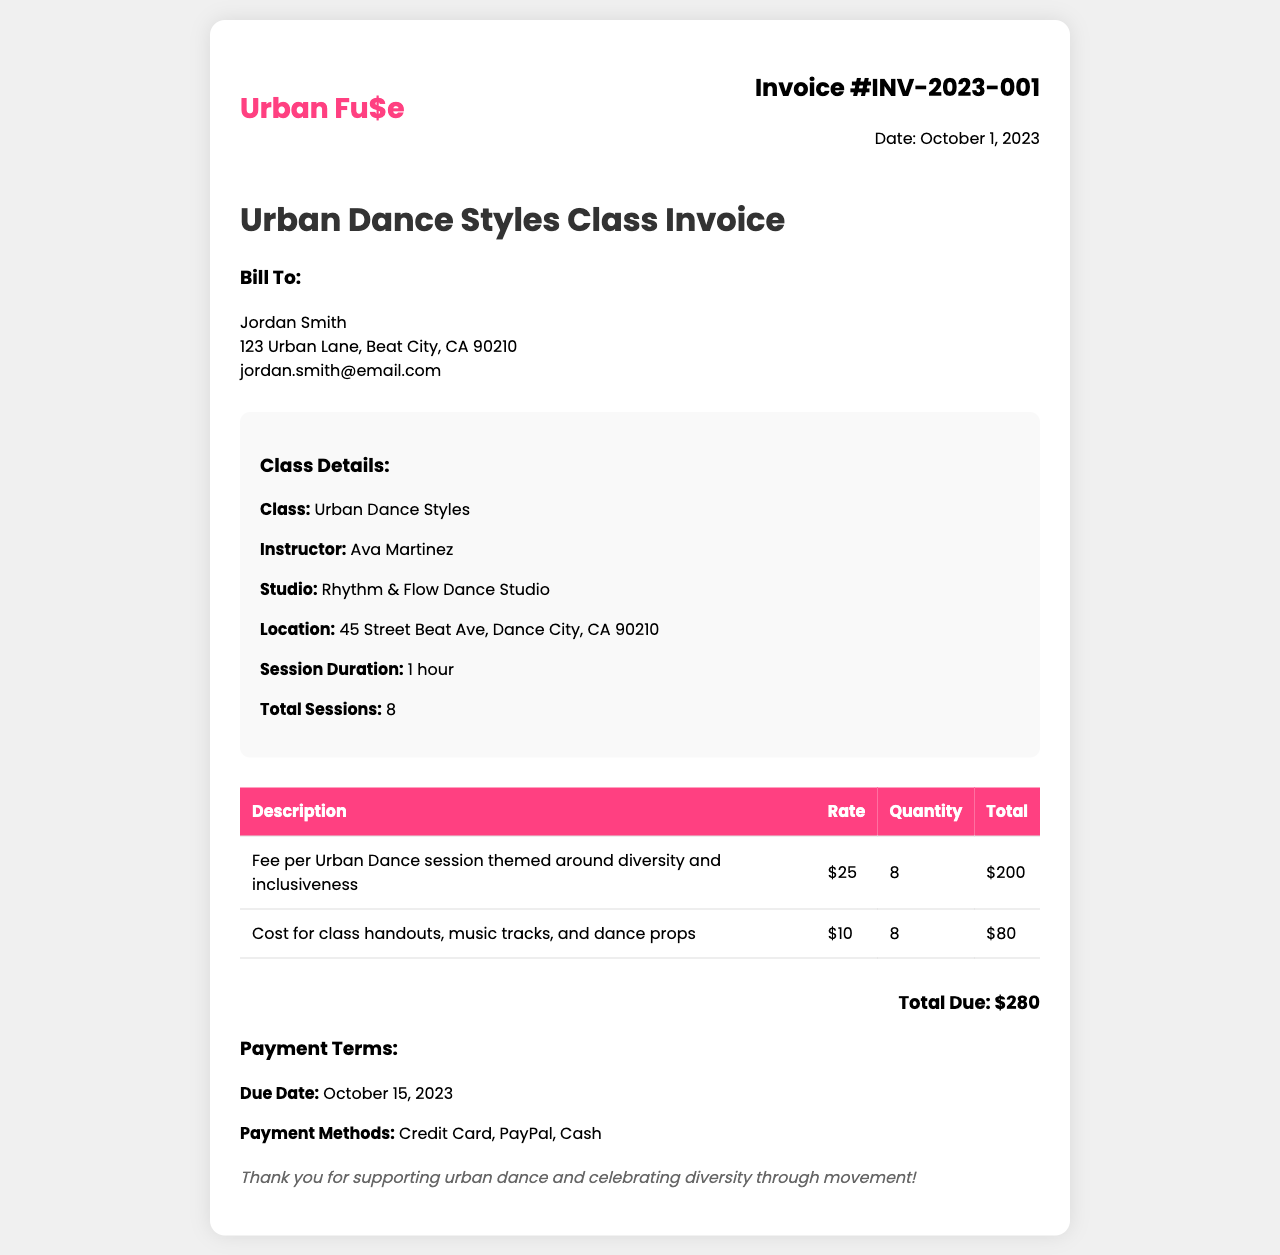What is the invoice number? The invoice number is specified at the top of the document, which is INV-2023-001.
Answer: INV-2023-001 Who is the instructor for the dance class? The instructor's name is mentioned in the class details section of the document as Ava Martinez.
Answer: Ava Martinez How many total sessions are included in the invoice? The total sessions are listed under class details, which is 8.
Answer: 8 What is the total due amount? The total amount due is shown at the bottom of the invoice, which is $280.
Answer: $280 What is the rate per Urban Dance session? The rate per session is stated in the table, which is $25.
Answer: $25 What materials are included in the class cost? The document specifies the cost for class handouts, music tracks, and dance props under class expenses.
Answer: Class handouts, music tracks, and dance props When is the payment due date? The due date for payment is provided in the payment terms section as October 15, 2023.
Answer: October 15, 2023 How many payment methods are listed? The document mentions three payment methods under payment terms, which are Credit Card, PayPal, and Cash.
Answer: Three What type of dance styles does the class focus on? The class type is specified in the header of the invoice as Urban Dance Styles.
Answer: Urban Dance Styles 